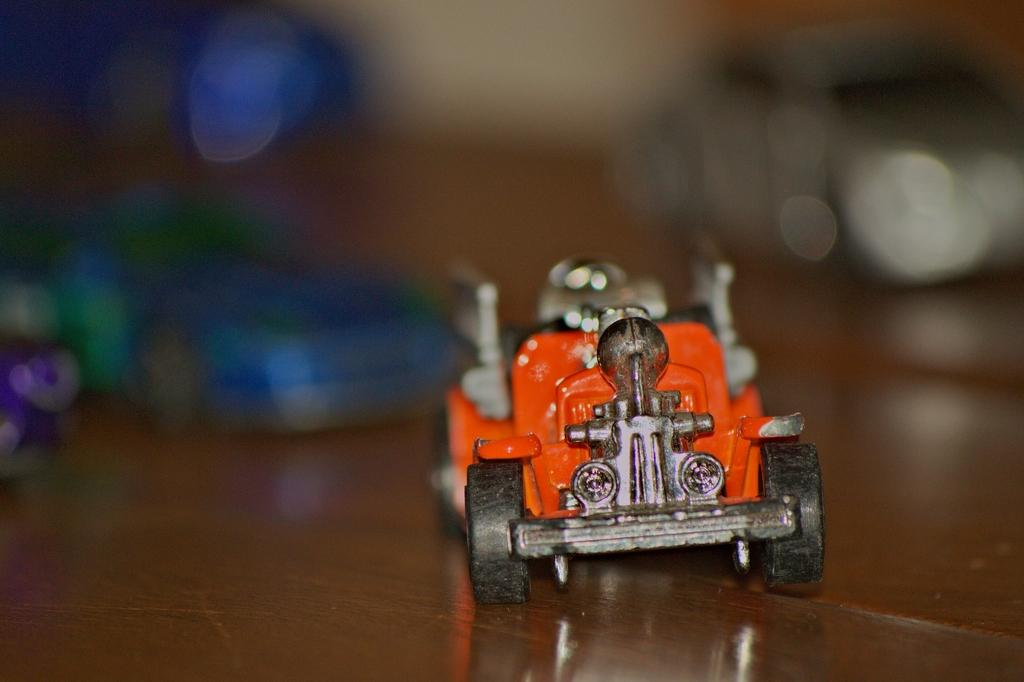What is the main object in the image? There is a toy car in the image. What color is the toy car? The toy car is orange in color. What piece of furniture is at the bottom of the image? There is a desk at the bottom of the image. Can you describe the background of the image? The background of the image is blurred. How many books are stacked on the canvas in the image? There are no books or canvas present in the image; it features a toy car and a desk. 